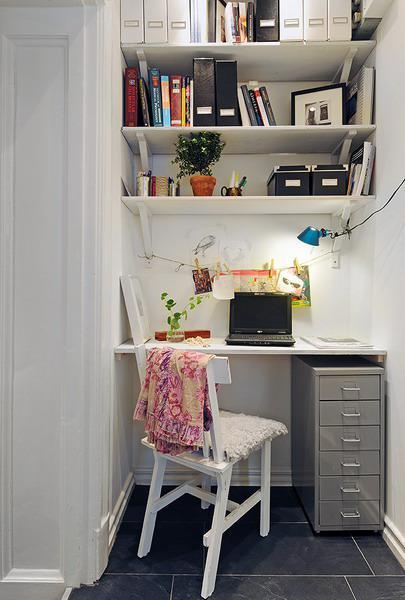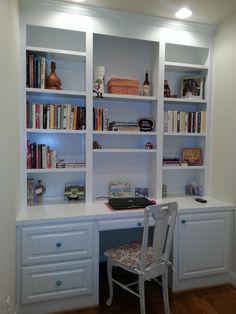The first image is the image on the left, the second image is the image on the right. Given the left and right images, does the statement "There is a four legged chair at each of the white desk areas." hold true? Answer yes or no. Yes. 